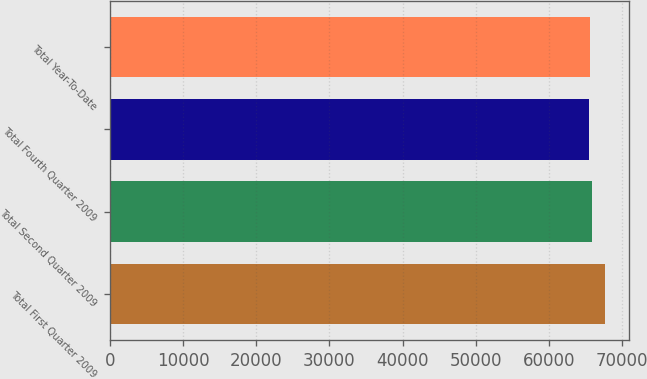Convert chart to OTSL. <chart><loc_0><loc_0><loc_500><loc_500><bar_chart><fcel>Total First Quarter 2009<fcel>Total Second Quarter 2009<fcel>Total Fourth Quarter 2009<fcel>Total Year-To-Date<nl><fcel>67657<fcel>65888.2<fcel>65446<fcel>65667.1<nl></chart> 